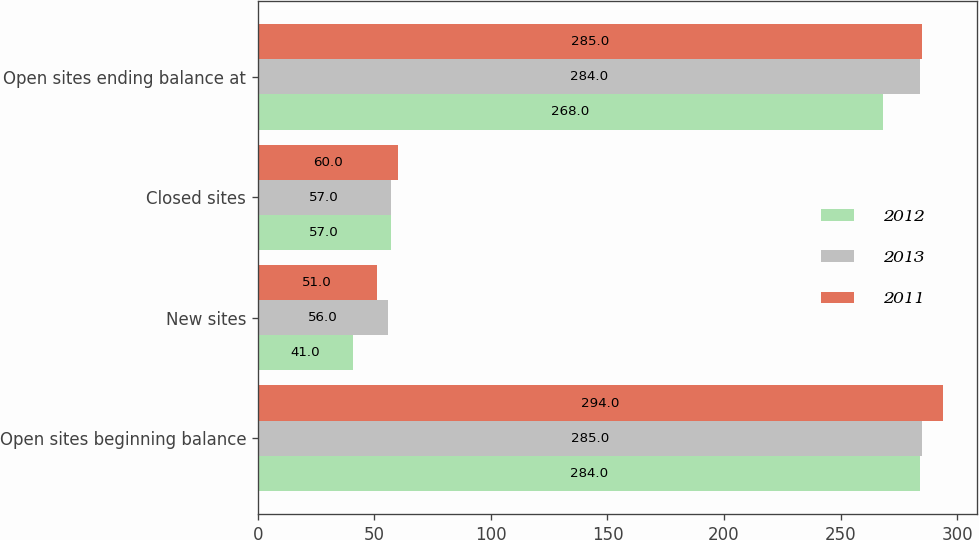Convert chart to OTSL. <chart><loc_0><loc_0><loc_500><loc_500><stacked_bar_chart><ecel><fcel>Open sites beginning balance<fcel>New sites<fcel>Closed sites<fcel>Open sites ending balance at<nl><fcel>2012<fcel>284<fcel>41<fcel>57<fcel>268<nl><fcel>2013<fcel>285<fcel>56<fcel>57<fcel>284<nl><fcel>2011<fcel>294<fcel>51<fcel>60<fcel>285<nl></chart> 